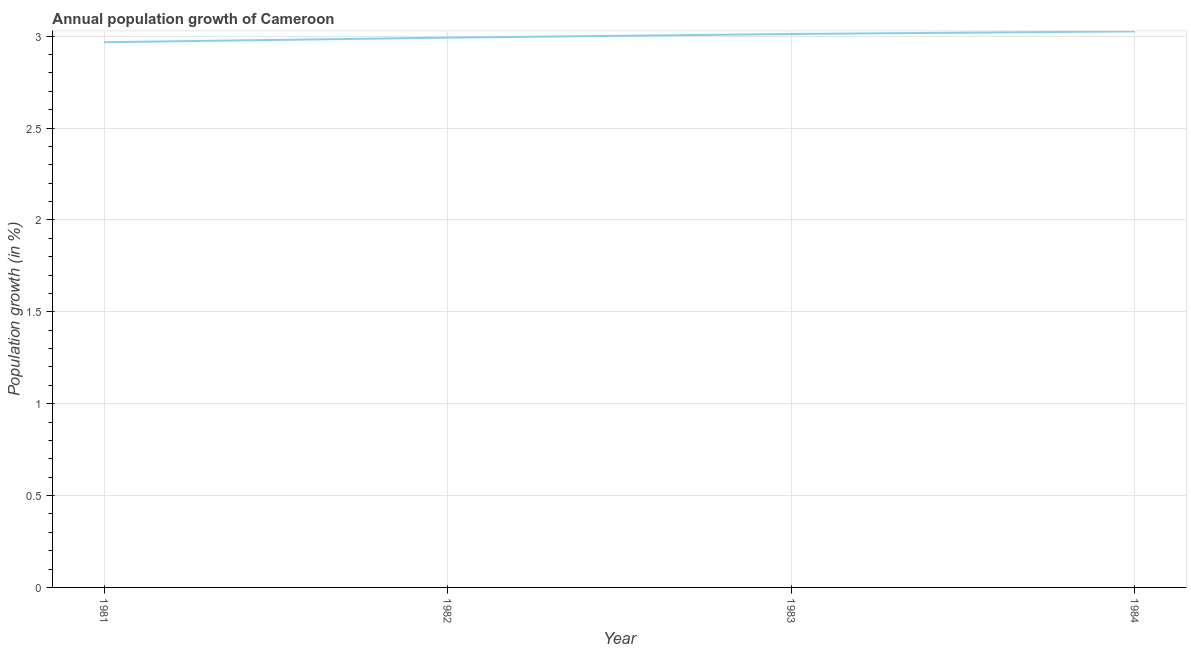What is the population growth in 1981?
Give a very brief answer. 2.97. Across all years, what is the maximum population growth?
Make the answer very short. 3.03. Across all years, what is the minimum population growth?
Make the answer very short. 2.97. What is the sum of the population growth?
Ensure brevity in your answer.  12. What is the difference between the population growth in 1981 and 1982?
Provide a succinct answer. -0.02. What is the average population growth per year?
Offer a very short reply. 3. What is the median population growth?
Your response must be concise. 3. What is the ratio of the population growth in 1982 to that in 1983?
Keep it short and to the point. 0.99. Is the difference between the population growth in 1981 and 1983 greater than the difference between any two years?
Offer a very short reply. No. What is the difference between the highest and the second highest population growth?
Ensure brevity in your answer.  0.01. Is the sum of the population growth in 1981 and 1983 greater than the maximum population growth across all years?
Keep it short and to the point. Yes. What is the difference between the highest and the lowest population growth?
Make the answer very short. 0.06. In how many years, is the population growth greater than the average population growth taken over all years?
Offer a terse response. 2. How many years are there in the graph?
Keep it short and to the point. 4. What is the title of the graph?
Your response must be concise. Annual population growth of Cameroon. What is the label or title of the X-axis?
Give a very brief answer. Year. What is the label or title of the Y-axis?
Make the answer very short. Population growth (in %). What is the Population growth (in %) of 1981?
Offer a terse response. 2.97. What is the Population growth (in %) of 1982?
Provide a short and direct response. 2.99. What is the Population growth (in %) of 1983?
Offer a very short reply. 3.01. What is the Population growth (in %) in 1984?
Your answer should be compact. 3.03. What is the difference between the Population growth (in %) in 1981 and 1982?
Your response must be concise. -0.02. What is the difference between the Population growth (in %) in 1981 and 1983?
Provide a short and direct response. -0.04. What is the difference between the Population growth (in %) in 1981 and 1984?
Give a very brief answer. -0.06. What is the difference between the Population growth (in %) in 1982 and 1983?
Offer a very short reply. -0.02. What is the difference between the Population growth (in %) in 1982 and 1984?
Provide a short and direct response. -0.03. What is the difference between the Population growth (in %) in 1983 and 1984?
Keep it short and to the point. -0.01. What is the ratio of the Population growth (in %) in 1981 to that in 1982?
Your response must be concise. 0.99. What is the ratio of the Population growth (in %) in 1981 to that in 1983?
Ensure brevity in your answer.  0.98. What is the ratio of the Population growth (in %) in 1983 to that in 1984?
Your answer should be very brief. 0.99. 